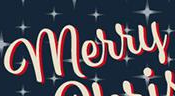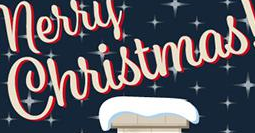What text appears in these images from left to right, separated by a semicolon? merry; Christmas 